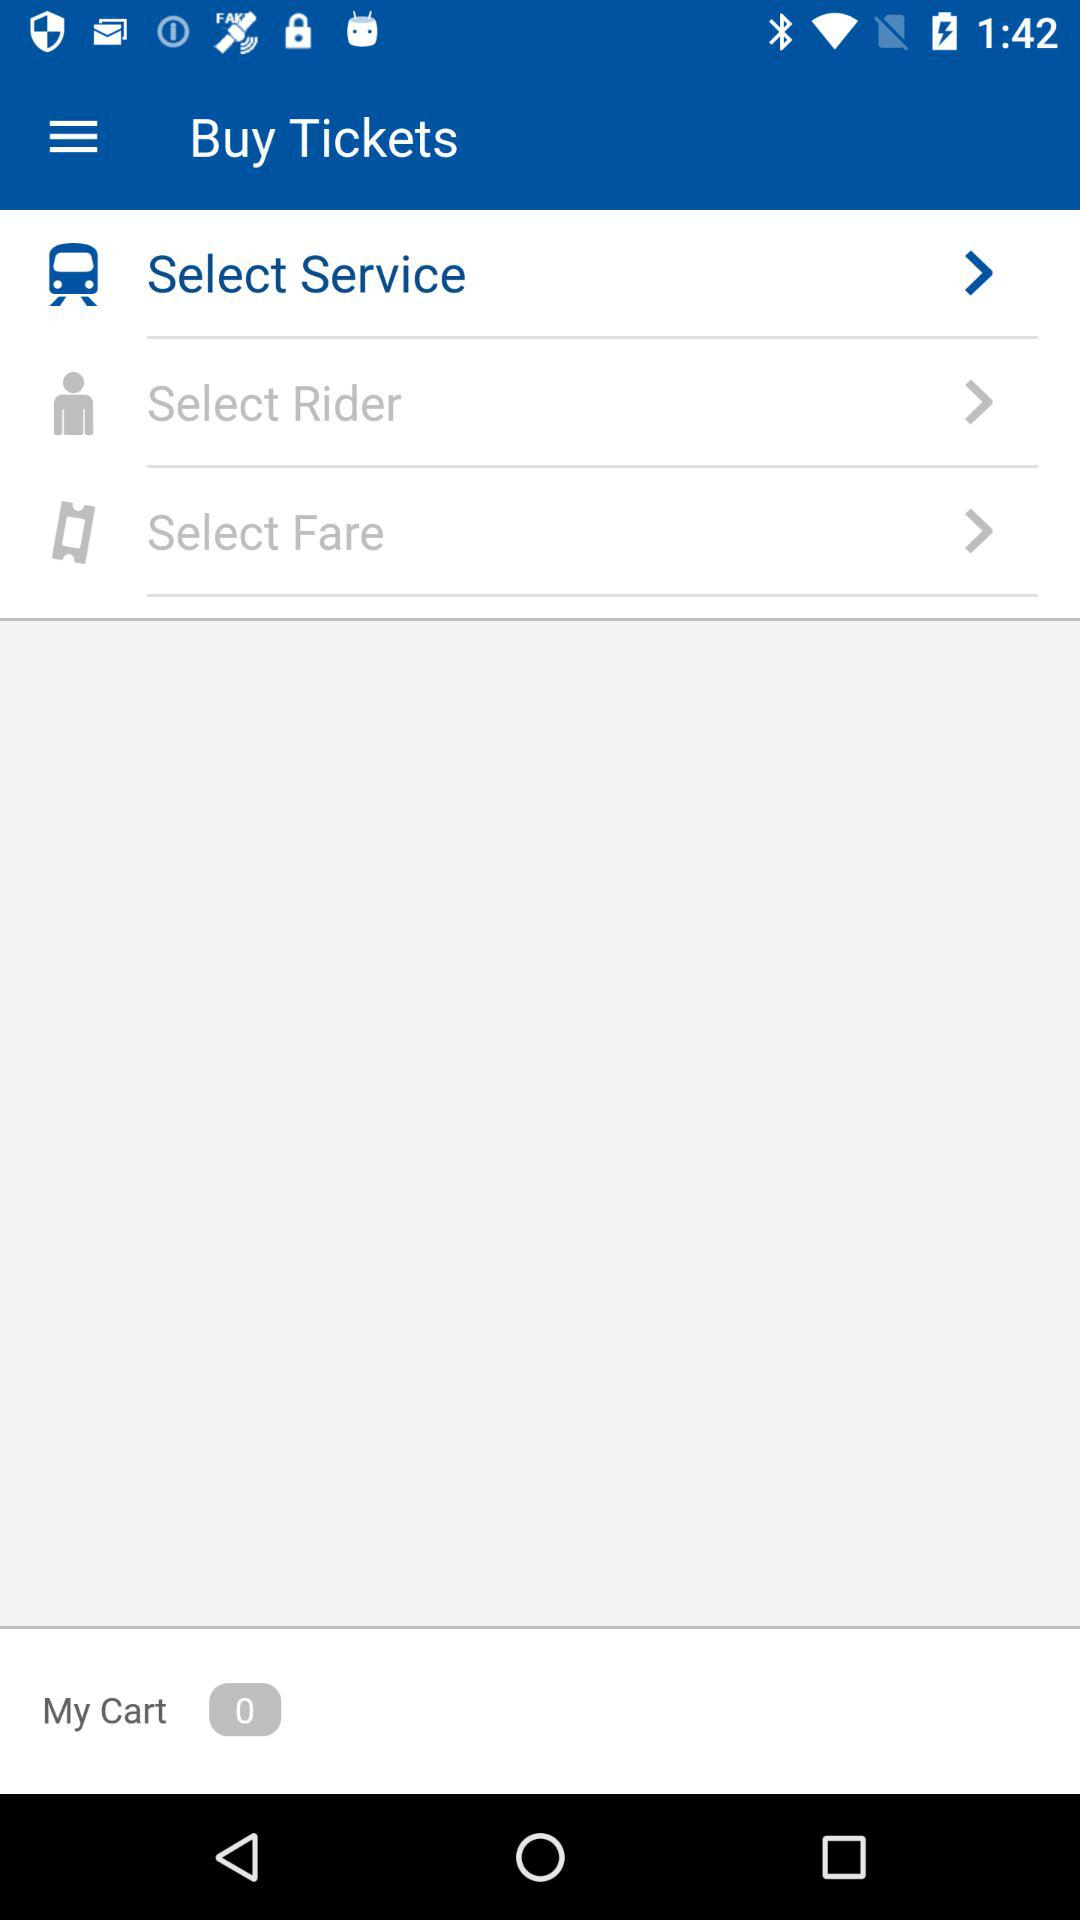What is the application name?
When the provided information is insufficient, respond with <no answer>. <no answer> 